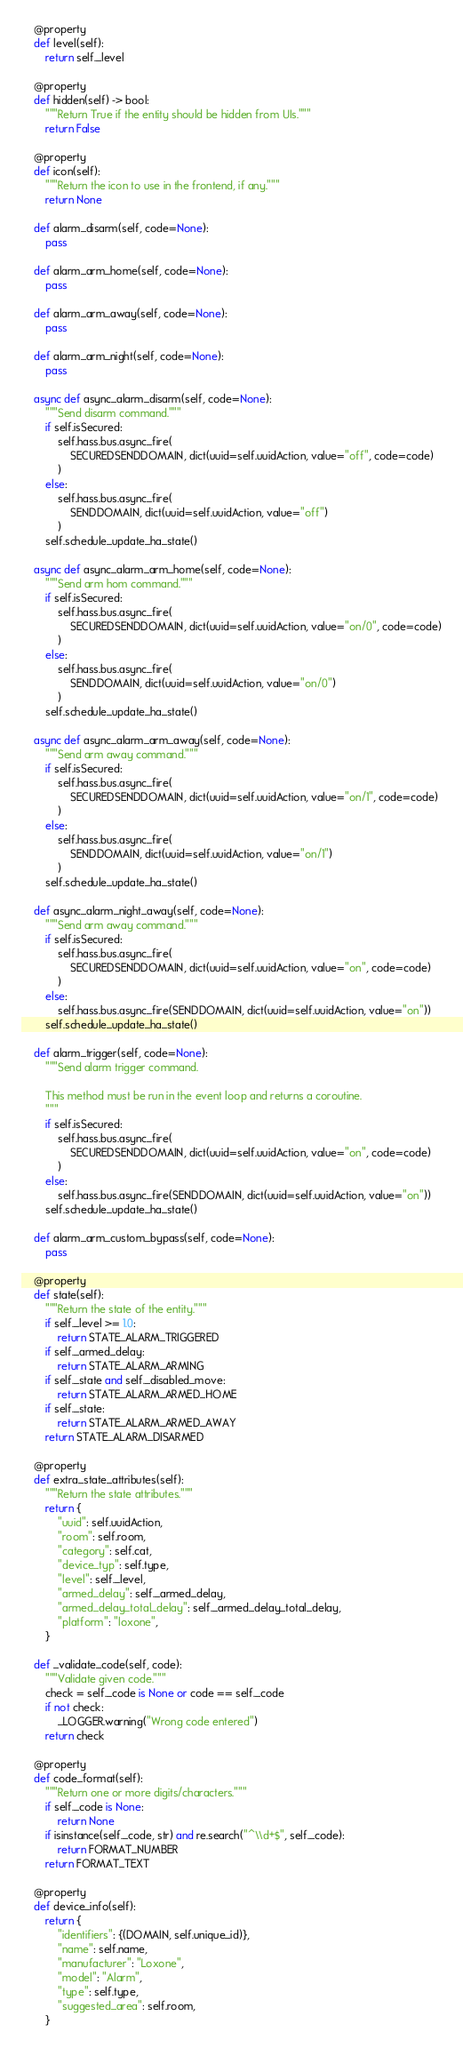<code> <loc_0><loc_0><loc_500><loc_500><_Python_>
    @property
    def level(self):
        return self._level

    @property
    def hidden(self) -> bool:
        """Return True if the entity should be hidden from UIs."""
        return False

    @property
    def icon(self):
        """Return the icon to use in the frontend, if any."""
        return None

    def alarm_disarm(self, code=None):
        pass

    def alarm_arm_home(self, code=None):
        pass

    def alarm_arm_away(self, code=None):
        pass

    def alarm_arm_night(self, code=None):
        pass

    async def async_alarm_disarm(self, code=None):
        """Send disarm command."""
        if self.isSecured:
            self.hass.bus.async_fire(
                SECUREDSENDDOMAIN, dict(uuid=self.uuidAction, value="off", code=code)
            )
        else:
            self.hass.bus.async_fire(
                SENDDOMAIN, dict(uuid=self.uuidAction, value="off")
            )
        self.schedule_update_ha_state()

    async def async_alarm_arm_home(self, code=None):
        """Send arm hom command."""
        if self.isSecured:
            self.hass.bus.async_fire(
                SECUREDSENDDOMAIN, dict(uuid=self.uuidAction, value="on/0", code=code)
            )
        else:
            self.hass.bus.async_fire(
                SENDDOMAIN, dict(uuid=self.uuidAction, value="on/0")
            )
        self.schedule_update_ha_state()

    async def async_alarm_arm_away(self, code=None):
        """Send arm away command."""
        if self.isSecured:
            self.hass.bus.async_fire(
                SECUREDSENDDOMAIN, dict(uuid=self.uuidAction, value="on/1", code=code)
            )
        else:
            self.hass.bus.async_fire(
                SENDDOMAIN, dict(uuid=self.uuidAction, value="on/1")
            )
        self.schedule_update_ha_state()

    def async_alarm_night_away(self, code=None):
        """Send arm away command."""
        if self.isSecured:
            self.hass.bus.async_fire(
                SECUREDSENDDOMAIN, dict(uuid=self.uuidAction, value="on", code=code)
            )
        else:
            self.hass.bus.async_fire(SENDDOMAIN, dict(uuid=self.uuidAction, value="on"))
        self.schedule_update_ha_state()

    def alarm_trigger(self, code=None):
        """Send alarm trigger command.

        This method must be run in the event loop and returns a coroutine.
        """
        if self.isSecured:
            self.hass.bus.async_fire(
                SECUREDSENDDOMAIN, dict(uuid=self.uuidAction, value="on", code=code)
            )
        else:
            self.hass.bus.async_fire(SENDDOMAIN, dict(uuid=self.uuidAction, value="on"))
        self.schedule_update_ha_state()

    def alarm_arm_custom_bypass(self, code=None):
        pass

    @property
    def state(self):
        """Return the state of the entity."""
        if self._level >= 1.0:
            return STATE_ALARM_TRIGGERED
        if self._armed_delay:
            return STATE_ALARM_ARMING
        if self._state and self._disabled_move:
            return STATE_ALARM_ARMED_HOME
        if self._state:
            return STATE_ALARM_ARMED_AWAY
        return STATE_ALARM_DISARMED

    @property
    def extra_state_attributes(self):
        """Return the state attributes."""
        return {
            "uuid": self.uuidAction,
            "room": self.room,
            "category": self.cat,
            "device_typ": self.type,
            "level": self._level,
            "armed_delay": self._armed_delay,
            "armed_delay_total_delay": self._armed_delay_total_delay,
            "platform": "loxone",
        }

    def _validate_code(self, code):
        """Validate given code."""
        check = self._code is None or code == self._code
        if not check:
            _LOGGER.warning("Wrong code entered")
        return check

    @property
    def code_format(self):
        """Return one or more digits/characters."""
        if self._code is None:
            return None
        if isinstance(self._code, str) and re.search("^\\d+$", self._code):
            return FORMAT_NUMBER
        return FORMAT_TEXT

    @property
    def device_info(self):
        return {
            "identifiers": {(DOMAIN, self.unique_id)},
            "name": self.name,
            "manufacturer": "Loxone",
            "model": "Alarm",
            "type": self.type,
            "suggested_area": self.room,
        }
</code> 